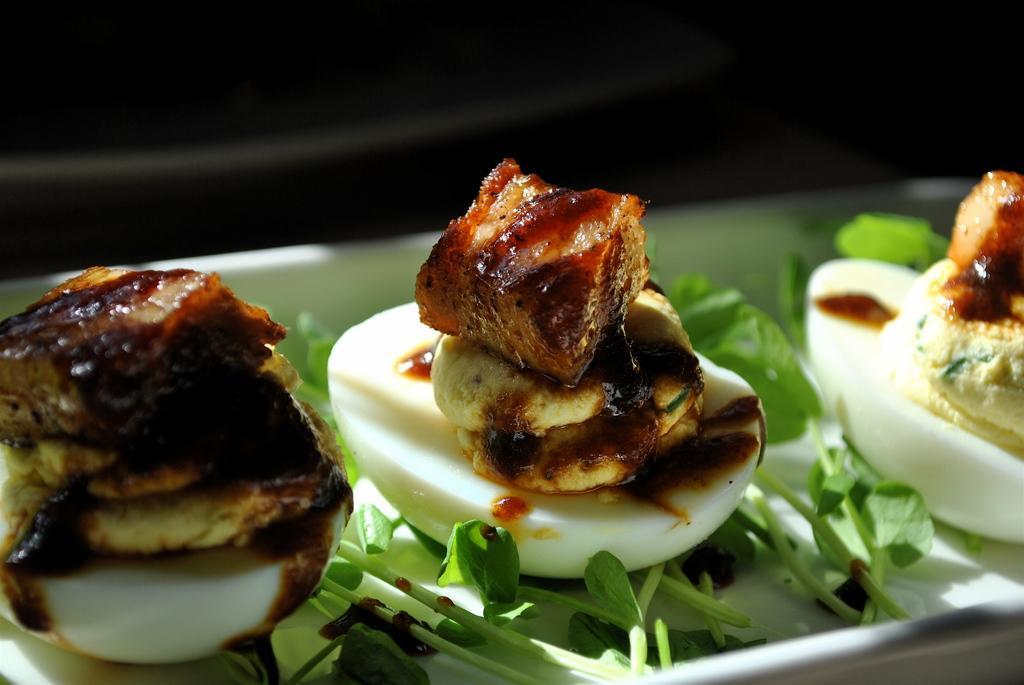Can you describe this image briefly? In this image, we can see a plate contains leaves and some food. 